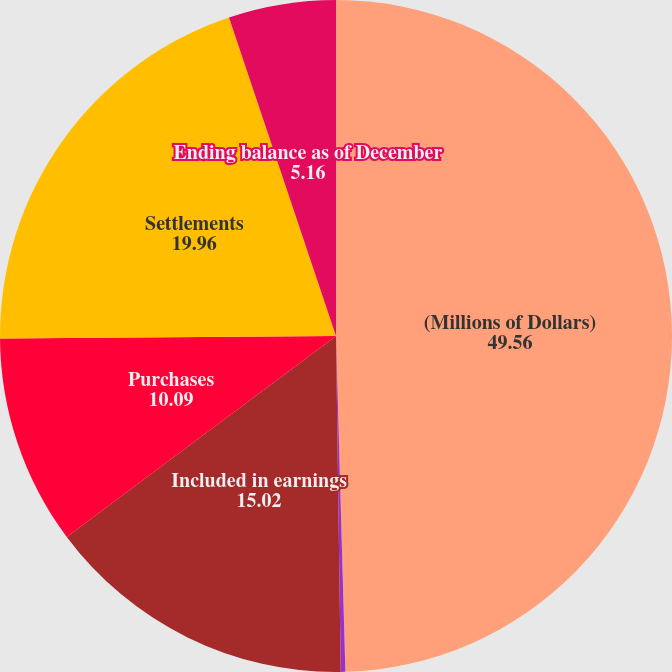Convert chart. <chart><loc_0><loc_0><loc_500><loc_500><pie_chart><fcel>(Millions of Dollars)<fcel>Beginning balance as of<fcel>Included in earnings<fcel>Purchases<fcel>Settlements<fcel>Ending balance as of December<nl><fcel>49.56%<fcel>0.22%<fcel>15.02%<fcel>10.09%<fcel>19.96%<fcel>5.16%<nl></chart> 